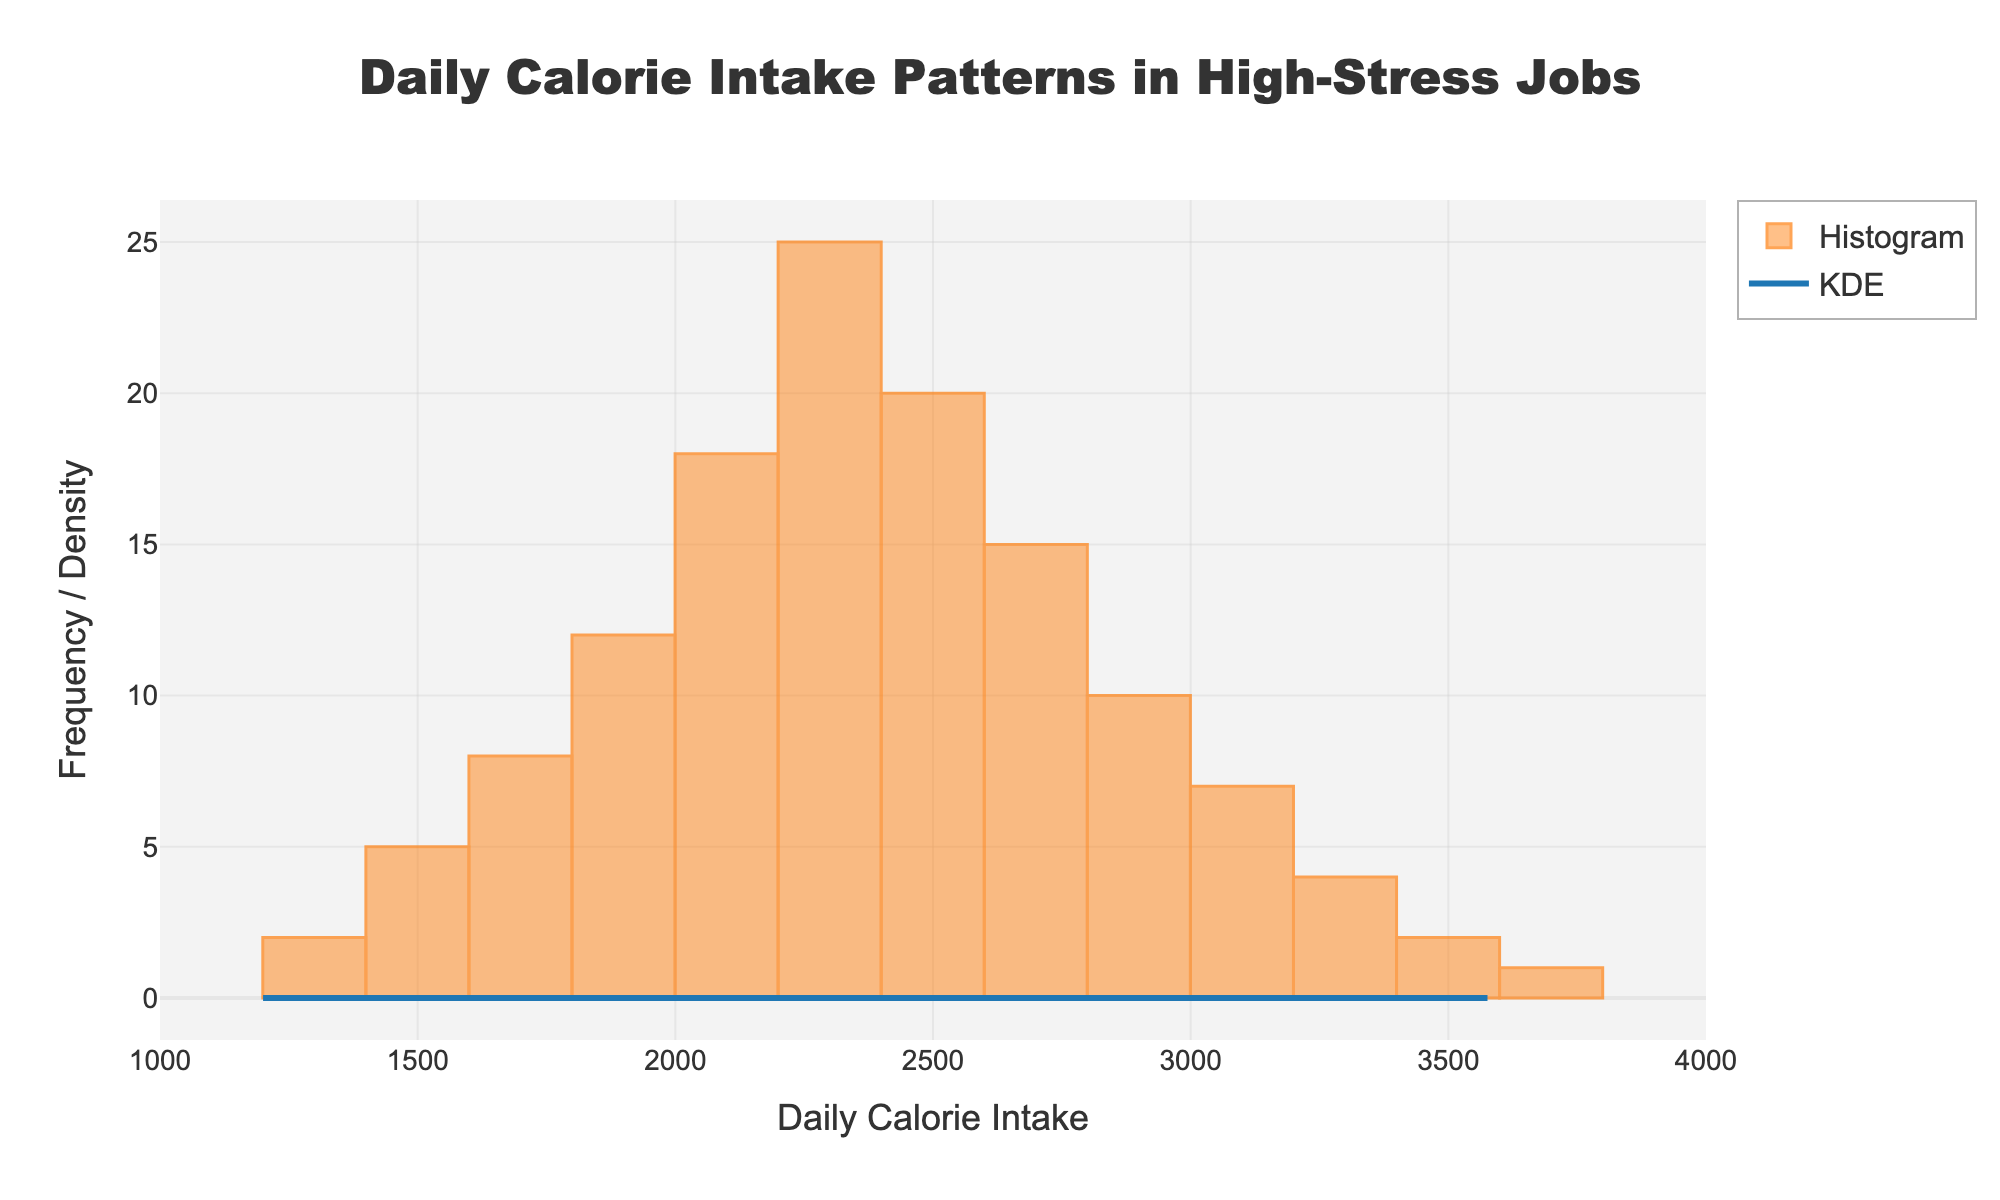What is the main title of the plot? The main title is located at the top of the figure and indicates the subject of the plot. Here, it says "Daily Calorie Intake Patterns in High-Stress Jobs."
Answer: Daily Calorie Intake Patterns in High-Stress Jobs What does the x-axis represent? The x-axis title is found below the horizontal axis and indicates the measurement being plotted. In this case, it is "Daily Calorie Intake."
Answer: Daily Calorie Intake What is the most frequent daily calorie intake range? By observing the histogram bars, the tallest bar represents the range with the highest frequency. The tallest bar appears between 2200 and 2400 calorie intake.
Answer: 2200-2400 Which calorie intake range appears least frequently? The shortest bars on the histogram indicate the least frequent ranges. The shortest bars are at 1200 and 3600 calorie intake.
Answer: 1200 and 3600 What color is used for the histogram bars? The color of the histogram bars is visually noticeable in the figure. It is an orange shade with some transparency.
Answer: Orange What color is used for the KDE line? The KDE line's color is prominently apparent as a bold line on the plot. It is a blue color.
Answer: Blue Which daily calorie intake range shows a peak in the KDE curve? The peak of the KDE curve represents the highest estimated density. This peak occurs around the 2200-2400 calorie intake range.
Answer: 2200-2400 Compare the frequency of daily calorie intake at 1800 and 3000. Which is greater? To compare the frequencies, look at the height of the bars at each calorie intake. The bar at 1800 is significantly taller than the bar at 3000.
Answer: 1800 calorie intake Is the distribution of daily calorie intake positively or negatively skewed? By examining the shape of the histogram and KDE curve, we can see a longer tail to the right side of the plot, indicating that the distribution is positively skewed.
Answer: Positively skewed How does the frequency distribution change as calorie intake increases from 1400 to 2600? By observing the histogram bars from 1400 to 2600, the frequency initially increases, peaks around 2200-2400, and then begins to decrease.
Answer: Frequency increases, peaks, then decreases 